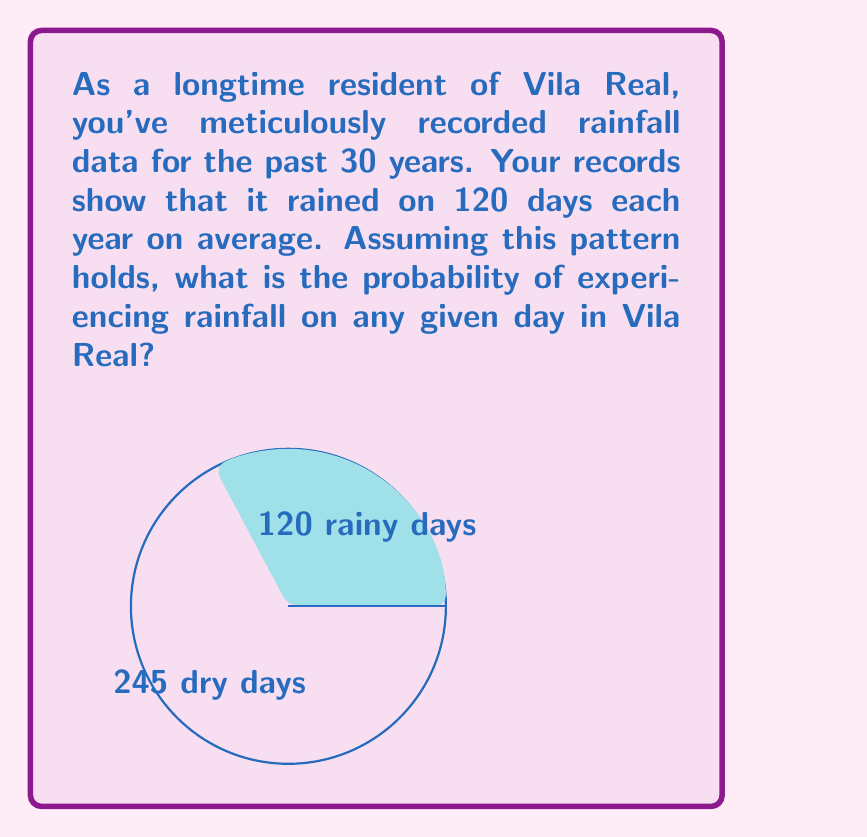Can you answer this question? To solve this problem, we'll use the concept of discrete probability. Here's a step-by-step approach:

1) First, we need to determine the total number of possible outcomes (total days in a year):
   $$ \text{Total days} = 365 $$

2) We're given that it rains on 120 days each year on average.

3) The probability of an event is calculated by dividing the number of favorable outcomes by the total number of possible outcomes:

   $$ P(\text{rain}) = \frac{\text{Number of rainy days}}{\text{Total number of days}} $$

4) Substituting our values:

   $$ P(\text{rain}) = \frac{120}{365} $$

5) Simplifying this fraction:

   $$ P(\text{rain}) = \frac{24}{73} \approx 0.3288 $$

6) We can express this as a percentage:

   $$ P(\text{rain}) \approx 32.88\% $$

Therefore, based on your long-term observations in Vila Real, the probability of rain on any given day is approximately 32.88% or about 1/3.
Answer: $\frac{24}{73}$ or approximately 32.88% 